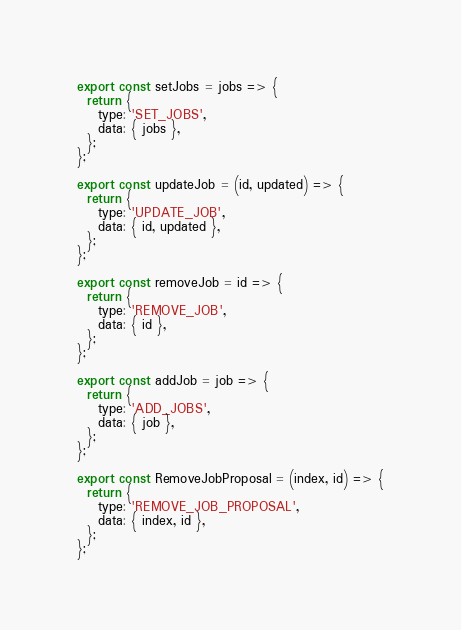Convert code to text. <code><loc_0><loc_0><loc_500><loc_500><_JavaScript_>export const setJobs = jobs => {
  return {
    type: 'SET_JOBS',
    data: { jobs },
  };
};

export const updateJob = (id, updated) => {
  return {
    type: 'UPDATE_JOB',
    data: { id, updated },
  };
};

export const removeJob = id => {
  return {
    type: 'REMOVE_JOB',
    data: { id },
  };
};

export const addJob = job => {
  return {
    type: 'ADD_JOBS',
    data: { job },
  };
};

export const RemoveJobProposal = (index, id) => {
  return {
    type: 'REMOVE_JOB_PROPOSAL',
    data: { index, id },
  };
};
</code> 